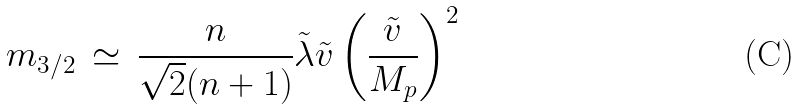Convert formula to latex. <formula><loc_0><loc_0><loc_500><loc_500>m _ { 3 / 2 } \, \simeq \, \frac { n } { \sqrt { 2 } ( n + 1 ) } \tilde { \lambda } \tilde { v } \left ( \frac { \tilde { v } } { M _ { p } } \right ) ^ { 2 }</formula> 